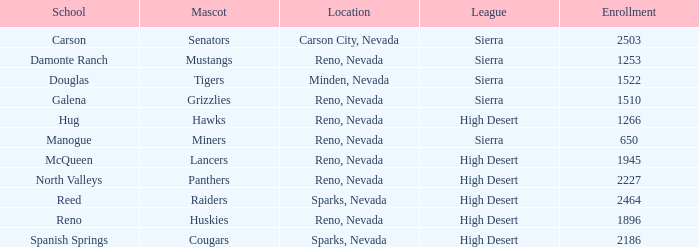Which leagues is the Galena school in? Sierra. 